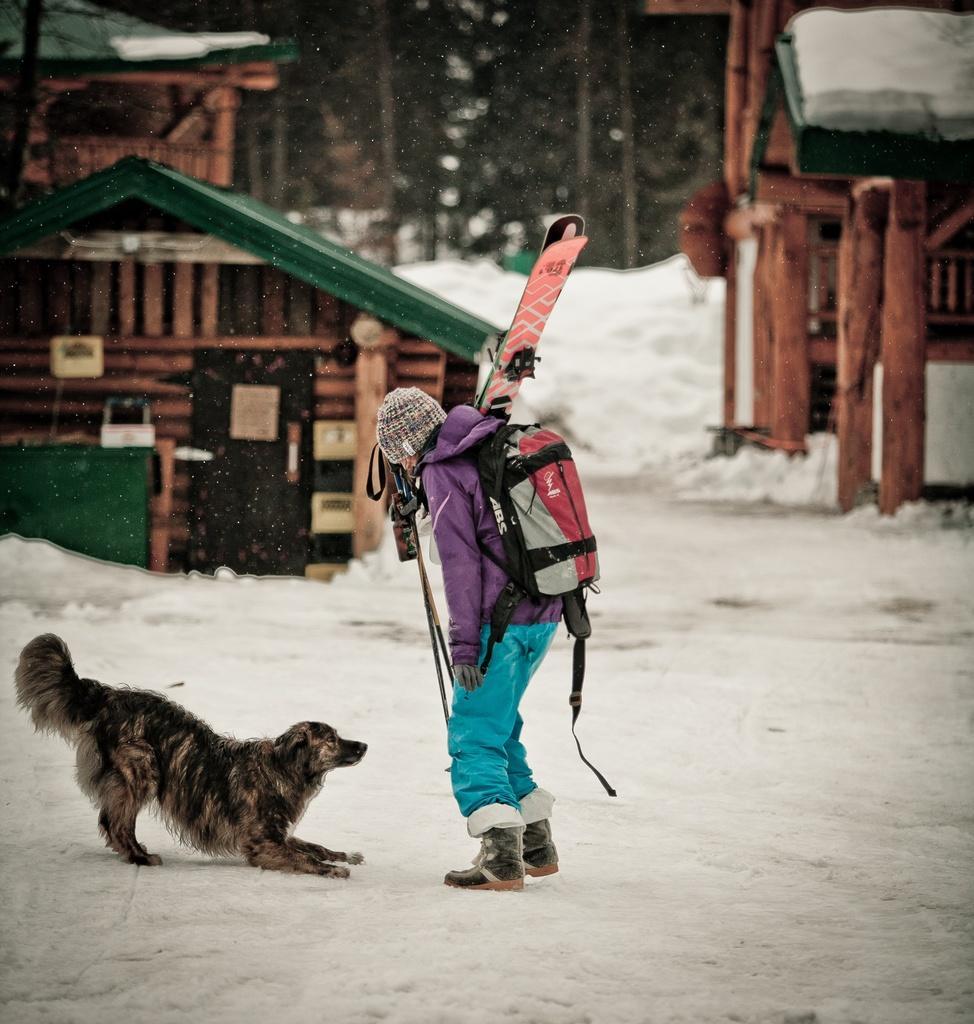Describe this image in one or two sentences. In this image we can see a person wearing a bag and we can also see dog, snow, houses and trees. 